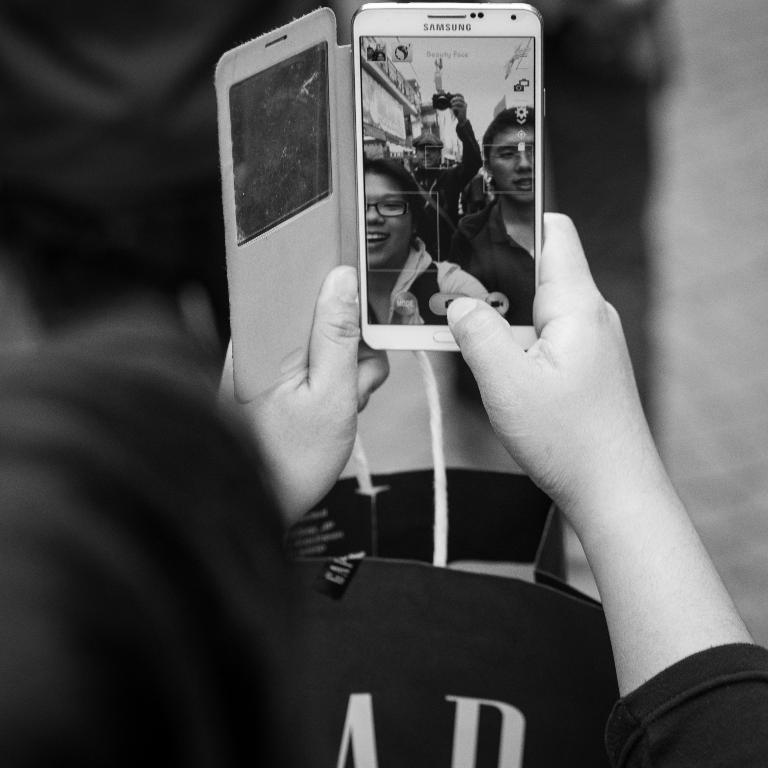<image>
Give a short and clear explanation of the subsequent image. a Samsung phone that a person has in their hand 